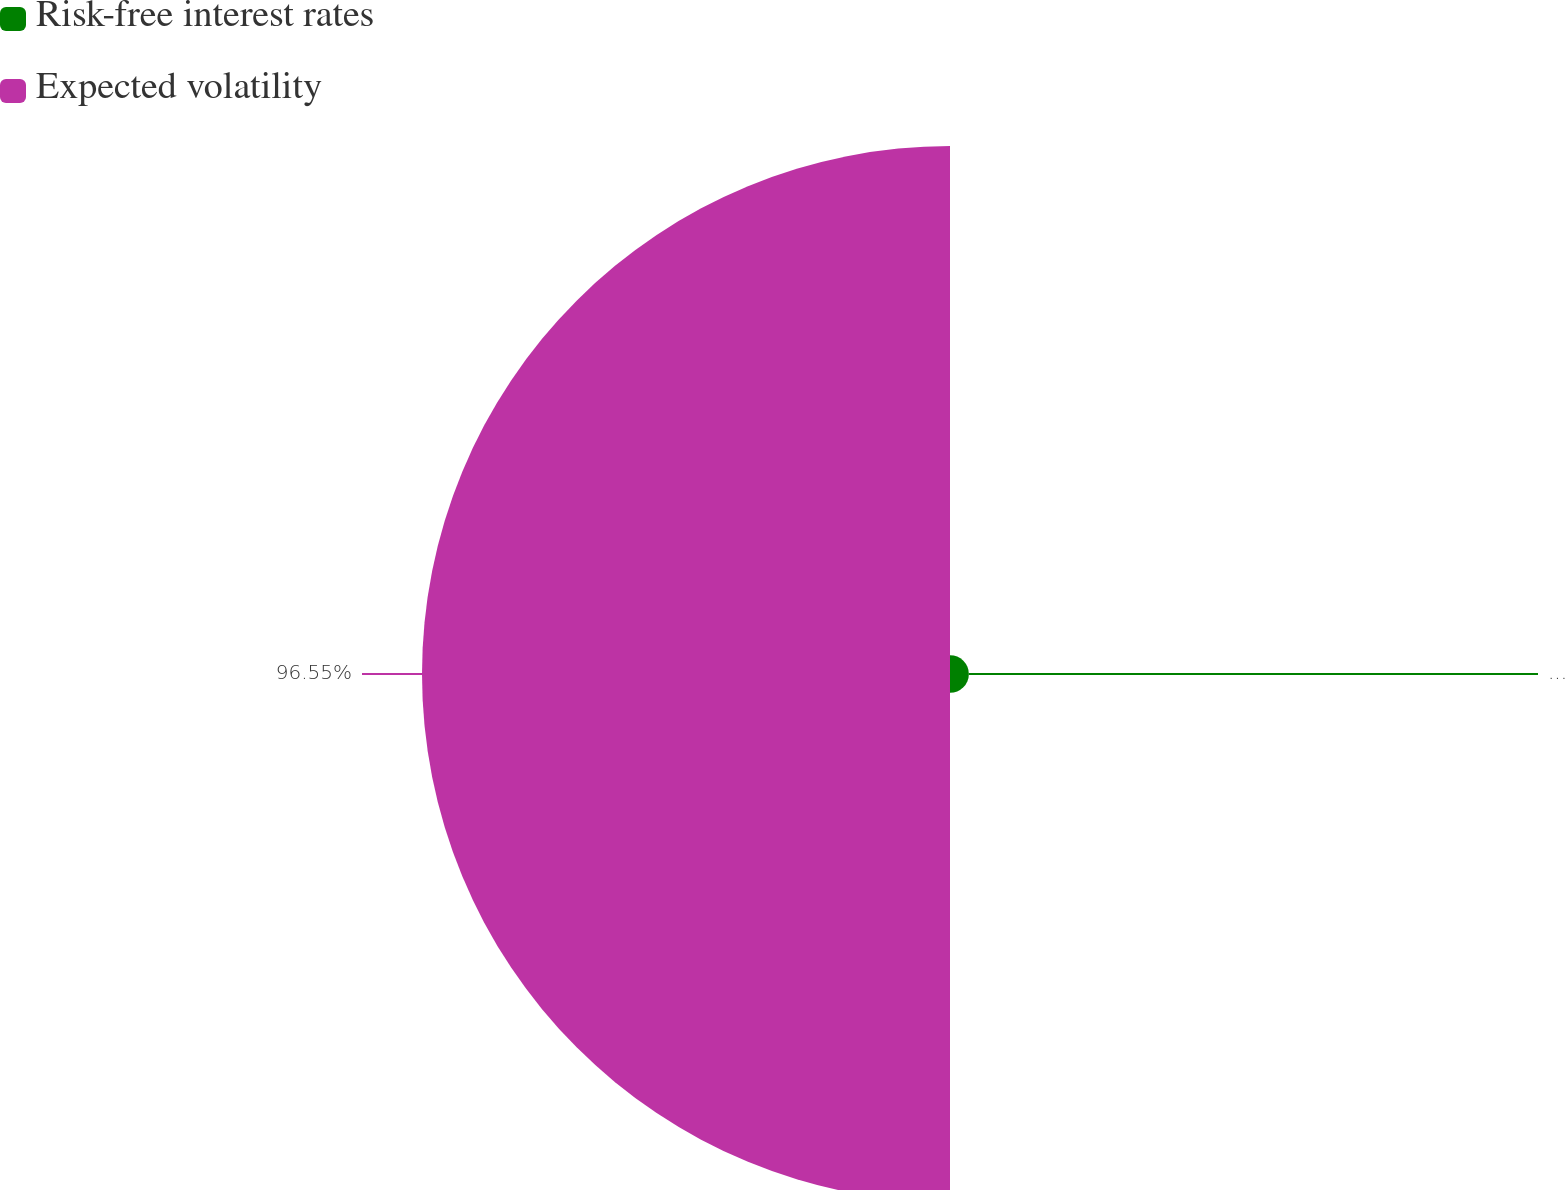Convert chart. <chart><loc_0><loc_0><loc_500><loc_500><pie_chart><fcel>Risk-free interest rates<fcel>Expected volatility<nl><fcel>3.45%<fcel>96.55%<nl></chart> 